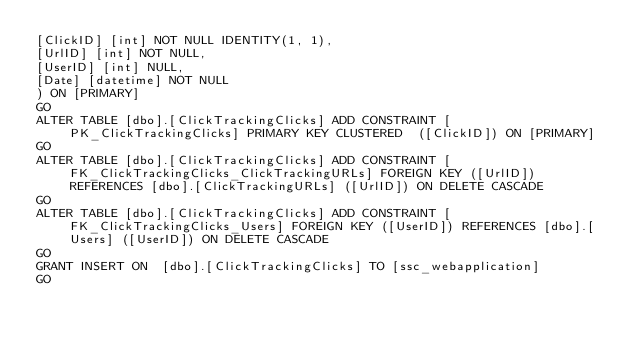Convert code to text. <code><loc_0><loc_0><loc_500><loc_500><_SQL_>[ClickID] [int] NOT NULL IDENTITY(1, 1),
[UrlID] [int] NOT NULL,
[UserID] [int] NULL,
[Date] [datetime] NOT NULL
) ON [PRIMARY]
GO
ALTER TABLE [dbo].[ClickTrackingClicks] ADD CONSTRAINT [PK_ClickTrackingClicks] PRIMARY KEY CLUSTERED  ([ClickID]) ON [PRIMARY]
GO
ALTER TABLE [dbo].[ClickTrackingClicks] ADD CONSTRAINT [FK_ClickTrackingClicks_ClickTrackingURLs] FOREIGN KEY ([UrlID]) REFERENCES [dbo].[ClickTrackingURLs] ([UrlID]) ON DELETE CASCADE
GO
ALTER TABLE [dbo].[ClickTrackingClicks] ADD CONSTRAINT [FK_ClickTrackingClicks_Users] FOREIGN KEY ([UserID]) REFERENCES [dbo].[Users] ([UserID]) ON DELETE CASCADE
GO
GRANT INSERT ON  [dbo].[ClickTrackingClicks] TO [ssc_webapplication]
GO
</code> 